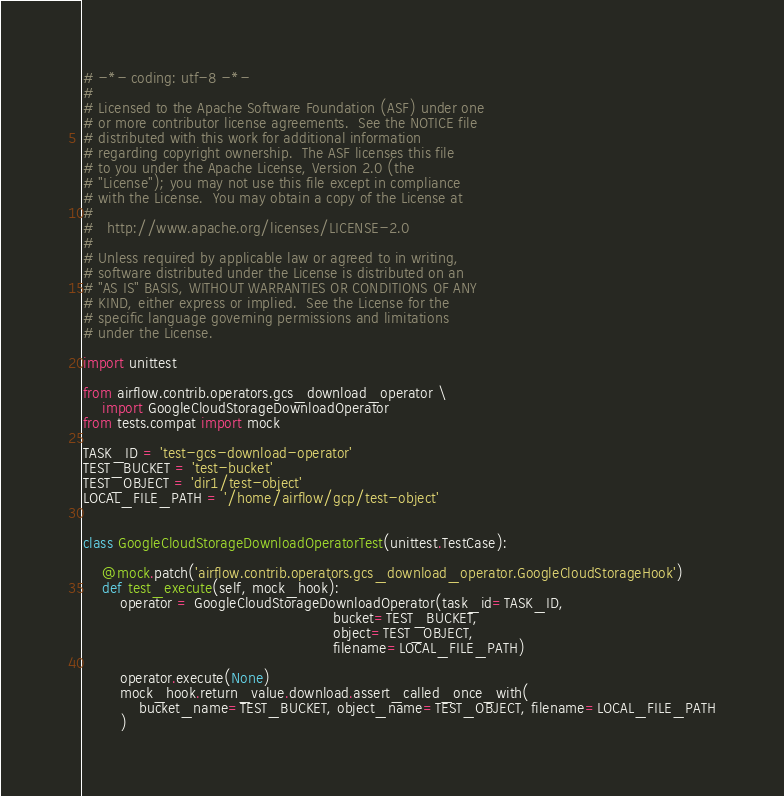Convert code to text. <code><loc_0><loc_0><loc_500><loc_500><_Python_># -*- coding: utf-8 -*-
#
# Licensed to the Apache Software Foundation (ASF) under one
# or more contributor license agreements.  See the NOTICE file
# distributed with this work for additional information
# regarding copyright ownership.  The ASF licenses this file
# to you under the Apache License, Version 2.0 (the
# "License"); you may not use this file except in compliance
# with the License.  You may obtain a copy of the License at
#
#   http://www.apache.org/licenses/LICENSE-2.0
#
# Unless required by applicable law or agreed to in writing,
# software distributed under the License is distributed on an
# "AS IS" BASIS, WITHOUT WARRANTIES OR CONDITIONS OF ANY
# KIND, either express or implied.  See the License for the
# specific language governing permissions and limitations
# under the License.

import unittest

from airflow.contrib.operators.gcs_download_operator \
    import GoogleCloudStorageDownloadOperator
from tests.compat import mock

TASK_ID = 'test-gcs-download-operator'
TEST_BUCKET = 'test-bucket'
TEST_OBJECT = 'dir1/test-object'
LOCAL_FILE_PATH = '/home/airflow/gcp/test-object'


class GoogleCloudStorageDownloadOperatorTest(unittest.TestCase):

    @mock.patch('airflow.contrib.operators.gcs_download_operator.GoogleCloudStorageHook')
    def test_execute(self, mock_hook):
        operator = GoogleCloudStorageDownloadOperator(task_id=TASK_ID,
                                                      bucket=TEST_BUCKET,
                                                      object=TEST_OBJECT,
                                                      filename=LOCAL_FILE_PATH)

        operator.execute(None)
        mock_hook.return_value.download.assert_called_once_with(
            bucket_name=TEST_BUCKET, object_name=TEST_OBJECT, filename=LOCAL_FILE_PATH
        )
</code> 